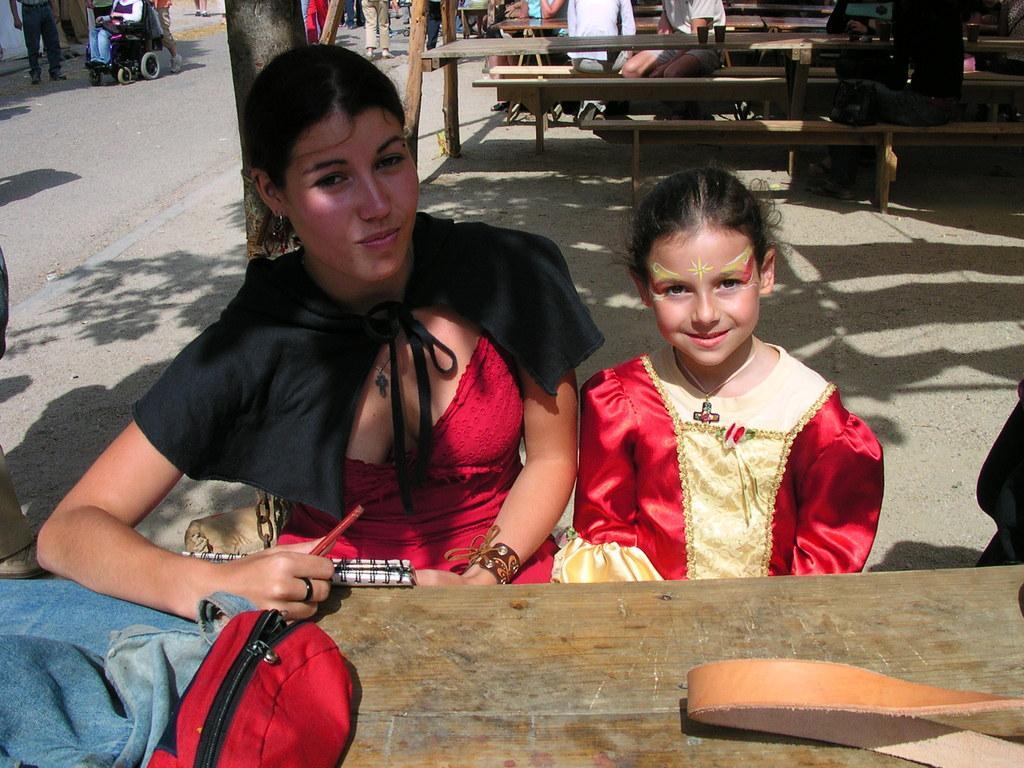How would you summarize this image in a sentence or two? A beautiful woman is sitting, she wore a red color dress. Beside her a little girl is sitting, she is smiling. In the left side there is a bag on this table. 